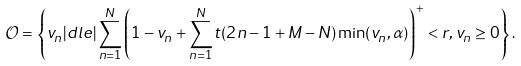<formula> <loc_0><loc_0><loc_500><loc_500>\mathcal { O } = \left \{ v _ { n } | d l e | \sum _ { n = 1 } ^ { N } \left ( 1 - v _ { n } + \sum _ { n = 1 } ^ { N } t ( 2 n - 1 + M - N ) \min ( v _ { n } , \alpha ) \right ) ^ { + } < r , v _ { n } \geq 0 \right \} .</formula> 